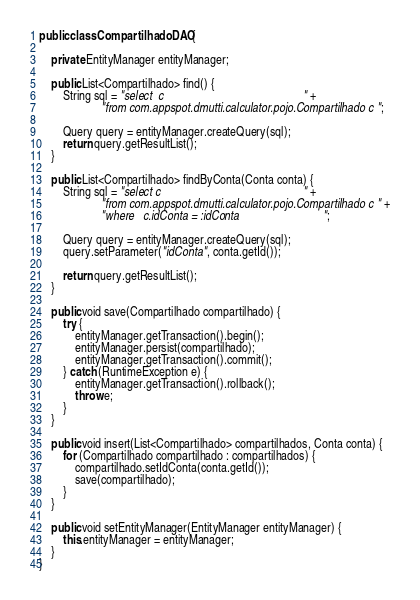<code> <loc_0><loc_0><loc_500><loc_500><_Java_>
public class CompartilhadoDAO {
    
    private EntityManager entityManager;
    
    public List<Compartilhado> find() {
        String sql = "select  c                                               " +
                     "from com.appspot.dmutti.calculator.pojo.Compartilhado c ";

        Query query = entityManager.createQuery(sql);
        return query.getResultList();
    }
    
    public List<Compartilhado> findByConta(Conta conta) {
        String sql = "select c                                                " +
                     "from com.appspot.dmutti.calculator.pojo.Compartilhado c " +
                     "where   c.idConta = :idConta                            ";

        Query query = entityManager.createQuery(sql);
        query.setParameter("idConta", conta.getId());

        return query.getResultList();
    }
    
    public void save(Compartilhado compartilhado) {
        try {
            entityManager.getTransaction().begin();
            entityManager.persist(compartilhado);
            entityManager.getTransaction().commit();
        } catch (RuntimeException e) {
            entityManager.getTransaction().rollback();
            throw e;
        }
    }
    
    public void insert(List<Compartilhado> compartilhados, Conta conta) {
        for (Compartilhado compartilhado : compartilhados) {
            compartilhado.setIdConta(conta.getId());
            save(compartilhado);
        }
    }

    public void setEntityManager(EntityManager entityManager) {
        this.entityManager = entityManager;
    }
}
</code> 